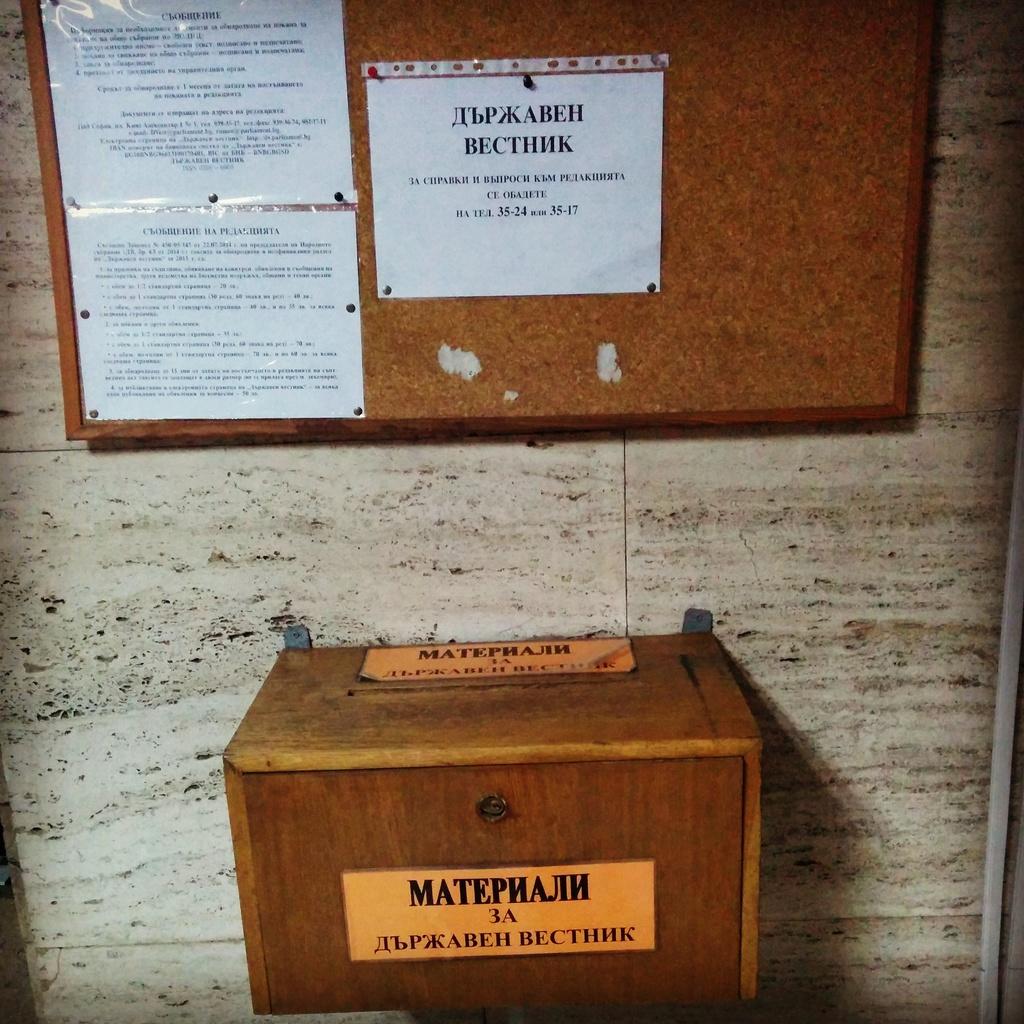What number is shown on the box label?
Your response must be concise. 3. 